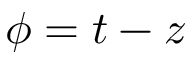Convert formula to latex. <formula><loc_0><loc_0><loc_500><loc_500>\phi = t - z</formula> 